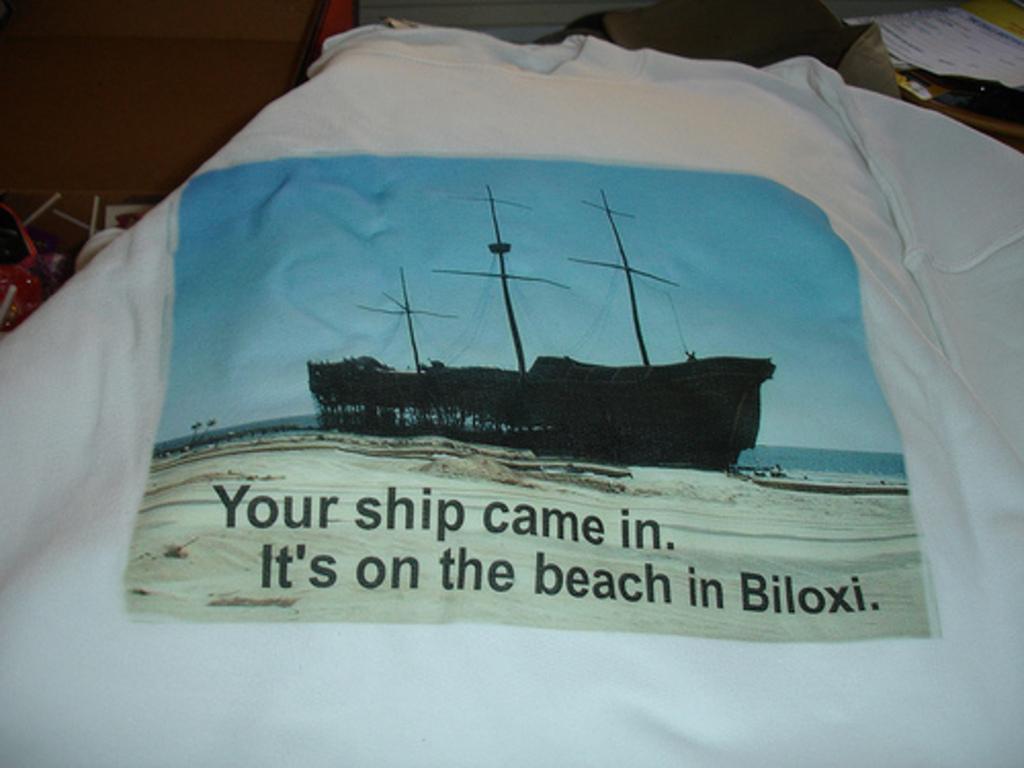How would you summarize this image in a sentence or two? In this picture we can see a print on the T-shirt. 